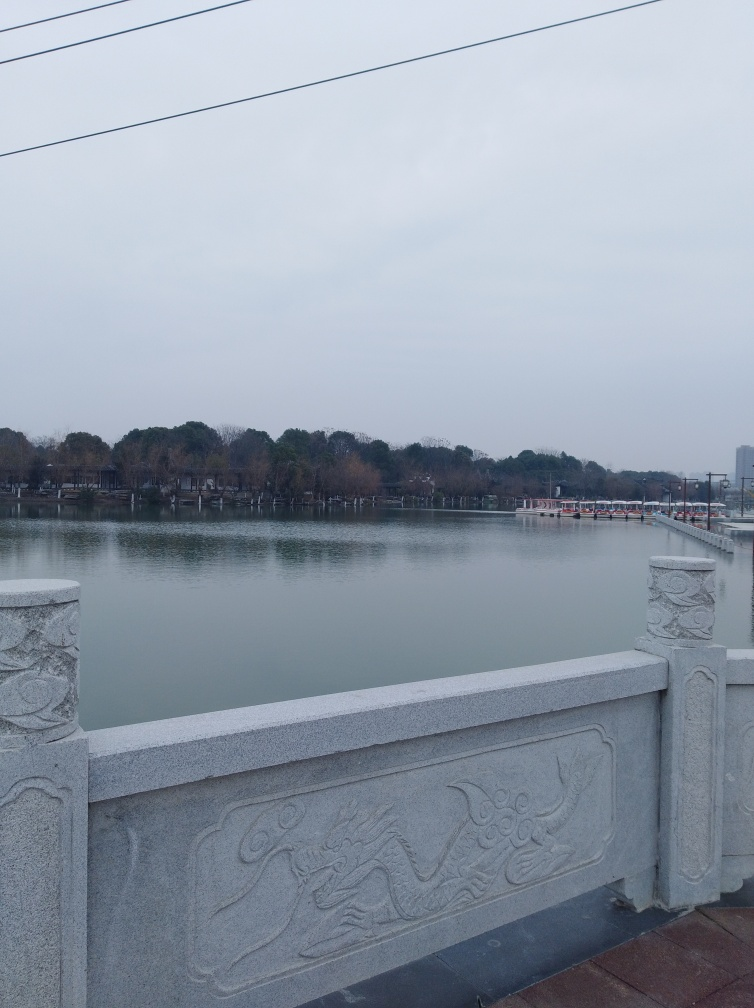What is the color tone of the image?
A. neutral
B. cooler
C. warmer
D. vibrant The color tone of the image leans toward a cooler palette. The overcast sky provides a soft diffusion of light which results in subdued, muted colors across the scene. The predominant shades of gray and soft blues contribute to this cooler ambiance, with the absence of vivid or warm colors. 